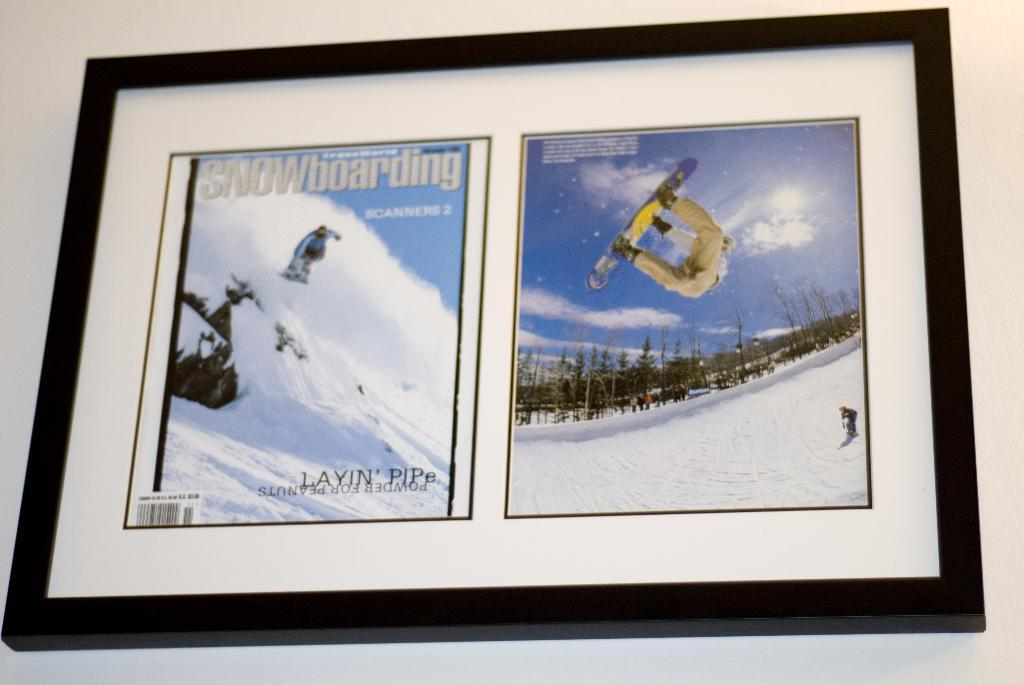<image>
Present a compact description of the photo's key features. A magazine cover from SNOWboarding magazine and a picture of a snowboarder are framed on a wall. 